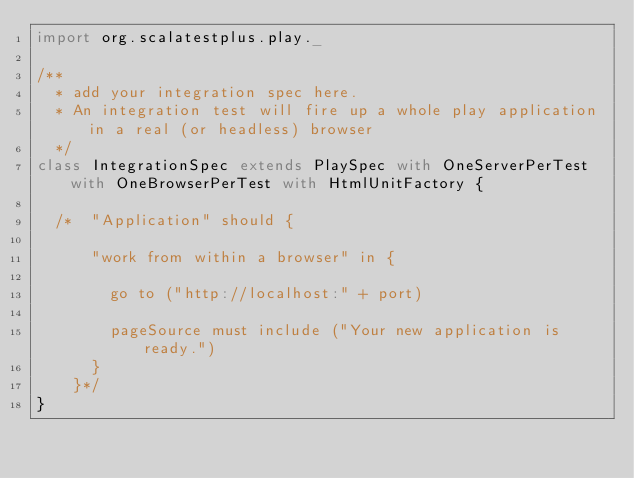Convert code to text. <code><loc_0><loc_0><loc_500><loc_500><_Scala_>import org.scalatestplus.play._

/**
  * add your integration spec here.
  * An integration test will fire up a whole play application in a real (or headless) browser
  */
class IntegrationSpec extends PlaySpec with OneServerPerTest with OneBrowserPerTest with HtmlUnitFactory {

  /*  "Application" should {

      "work from within a browser" in {

        go to ("http://localhost:" + port)

        pageSource must include ("Your new application is ready.")
      }
    }*/
}
</code> 